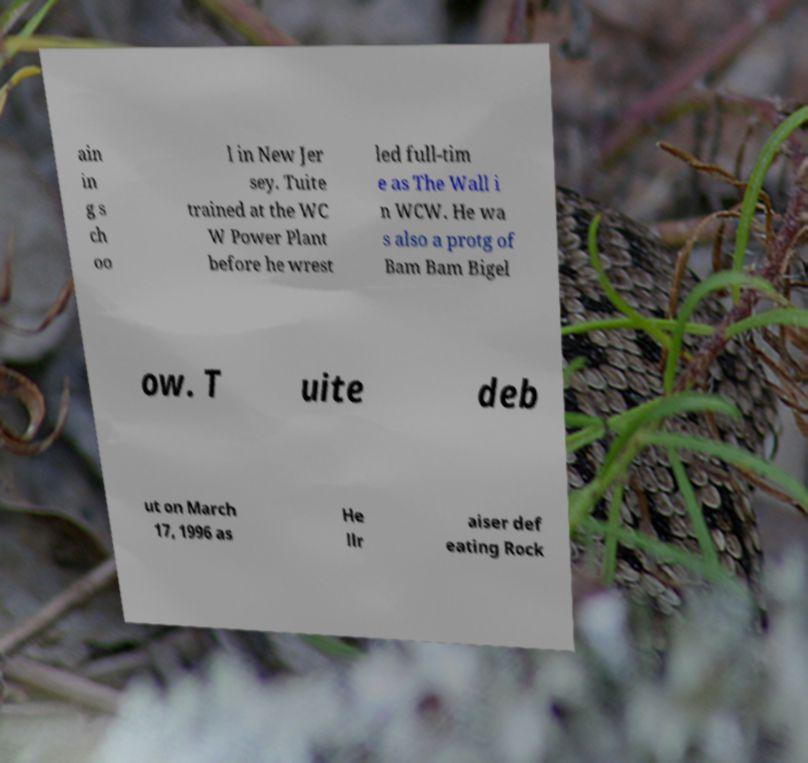Can you accurately transcribe the text from the provided image for me? ain in g s ch oo l in New Jer sey. Tuite trained at the WC W Power Plant before he wrest led full-tim e as The Wall i n WCW. He wa s also a protg of Bam Bam Bigel ow. T uite deb ut on March 17, 1996 as He llr aiser def eating Rock 